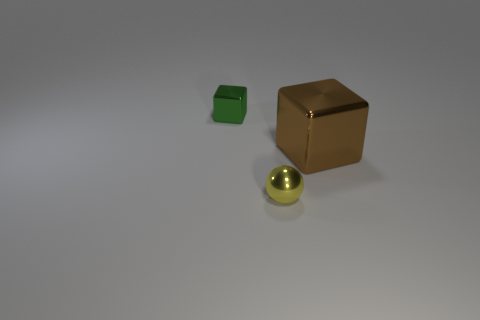Are there any other things that have the same shape as the small yellow object?
Provide a succinct answer. No. Are there fewer metallic objects that are behind the brown shiny thing than tiny metal objects?
Ensure brevity in your answer.  Yes. What number of metal things are small cubes or large cubes?
Give a very brief answer. 2. Is there anything else that has the same size as the brown shiny block?
Ensure brevity in your answer.  No. The large thing that is made of the same material as the small green block is what color?
Your answer should be very brief. Brown. How many cubes are green metal objects or brown shiny objects?
Ensure brevity in your answer.  2. How many things are tiny green metallic blocks or objects behind the brown object?
Offer a very short reply. 1. Are there any gray things?
Your answer should be very brief. No. What size is the cube right of the metallic object behind the big metal thing?
Offer a terse response. Large. Are there any other large blocks made of the same material as the big brown cube?
Keep it short and to the point. No. 